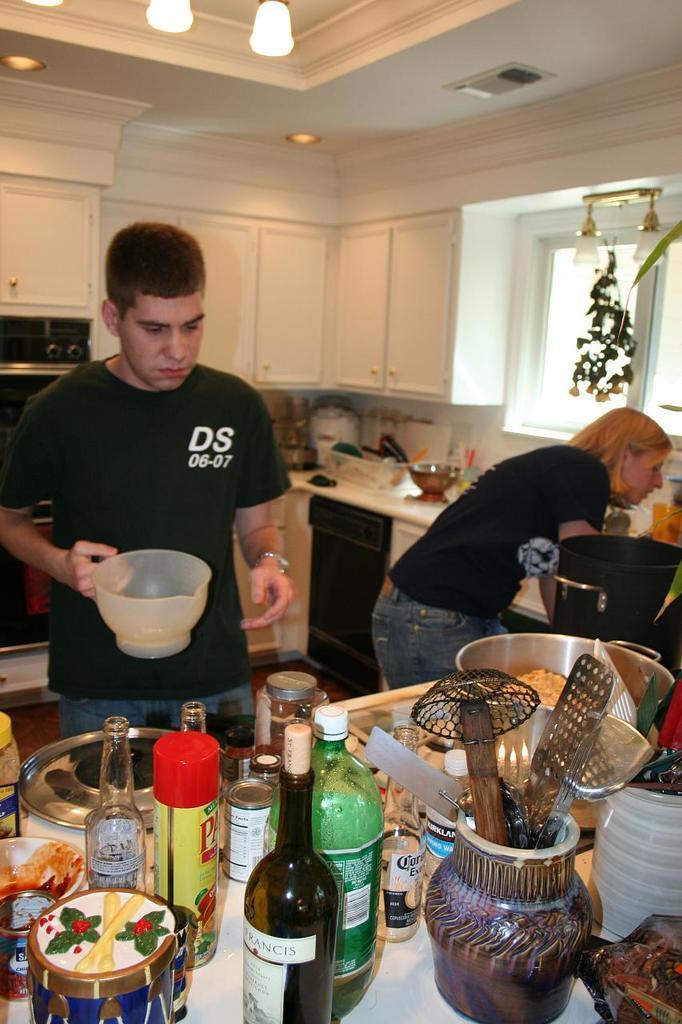Describe this image in one or two sentences. In this image I see a man and woman who are standing and this man is holding a bowl. On the corner top I see bottles, bowl and many other things. In the background I see the cabinets, window and lights on the ceiling. 